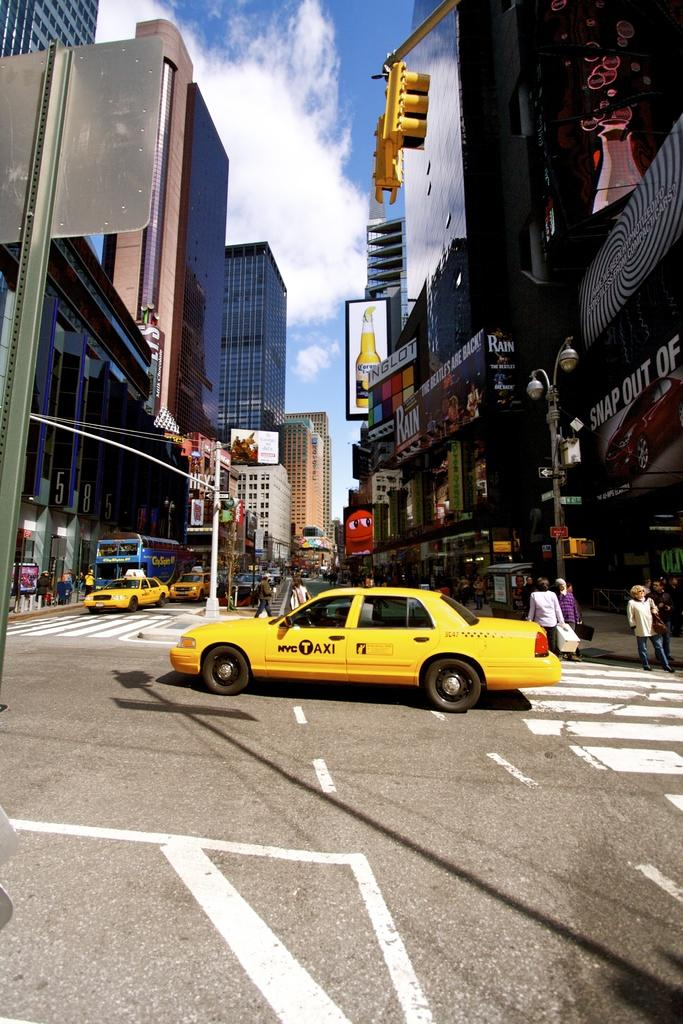Provide a one-sentence caption for the provided image. A NYC Taxi drives through an intersection in New York City. 